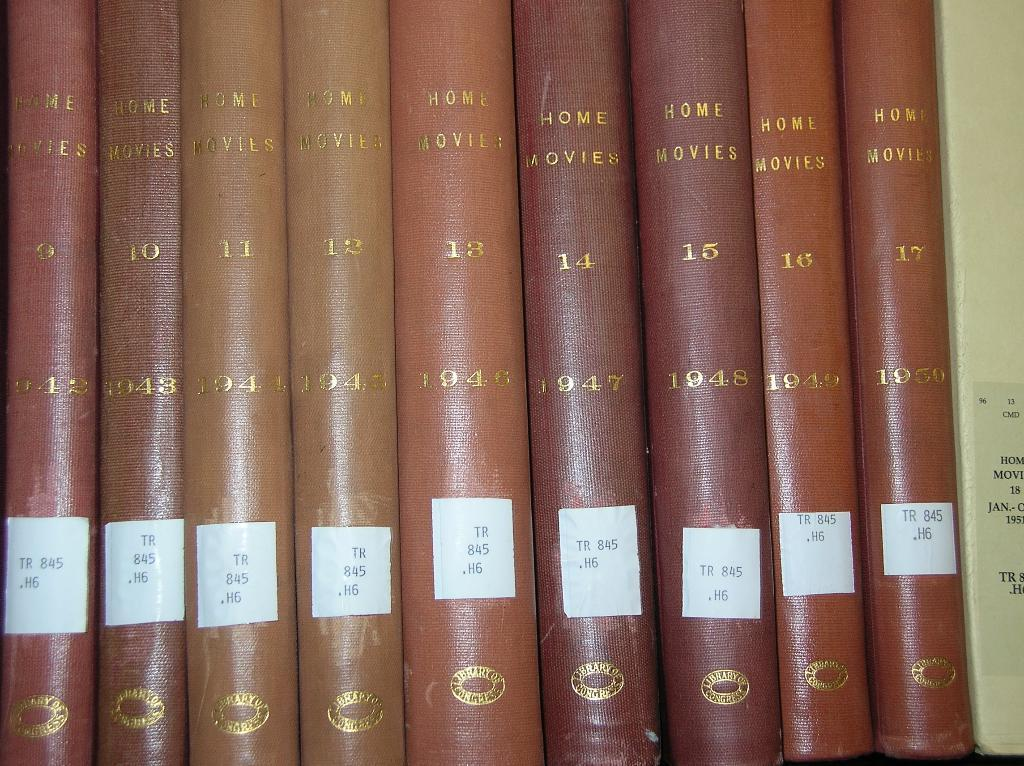Provide a one-sentence caption for the provided image. A series of leather bound books titled Home Movies. 